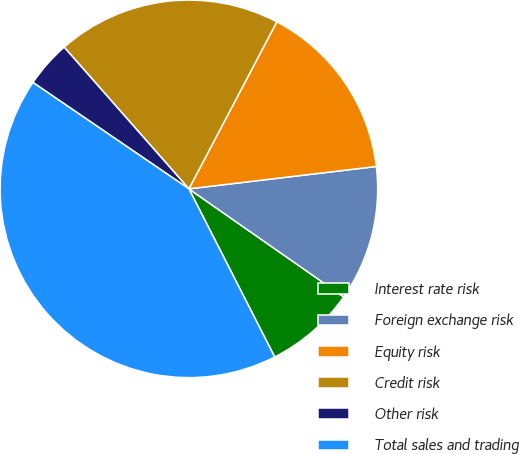Convert chart. <chart><loc_0><loc_0><loc_500><loc_500><pie_chart><fcel>Interest rate risk<fcel>Foreign exchange risk<fcel>Equity risk<fcel>Credit risk<fcel>Other risk<fcel>Total sales and trading<nl><fcel>7.79%<fcel>11.59%<fcel>15.4%<fcel>19.2%<fcel>3.98%<fcel>42.04%<nl></chart> 